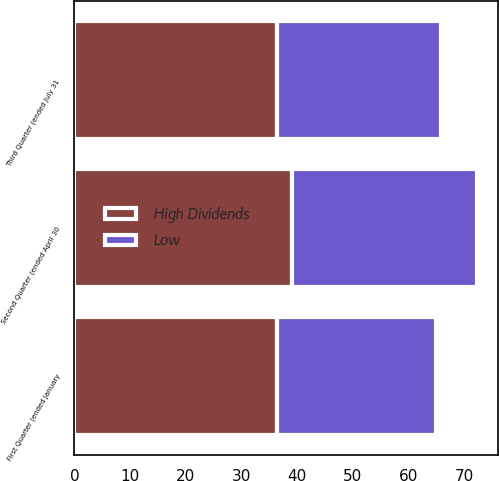Convert chart. <chart><loc_0><loc_0><loc_500><loc_500><stacked_bar_chart><ecel><fcel>First Quarter (ended January<fcel>Second Quarter (ended April 30<fcel>Third Quarter (ended July 31<nl><fcel>High Dividends<fcel>36.33<fcel>38.99<fcel>36.31<nl><fcel>Low<fcel>28.56<fcel>33.37<fcel>29.51<nl></chart> 